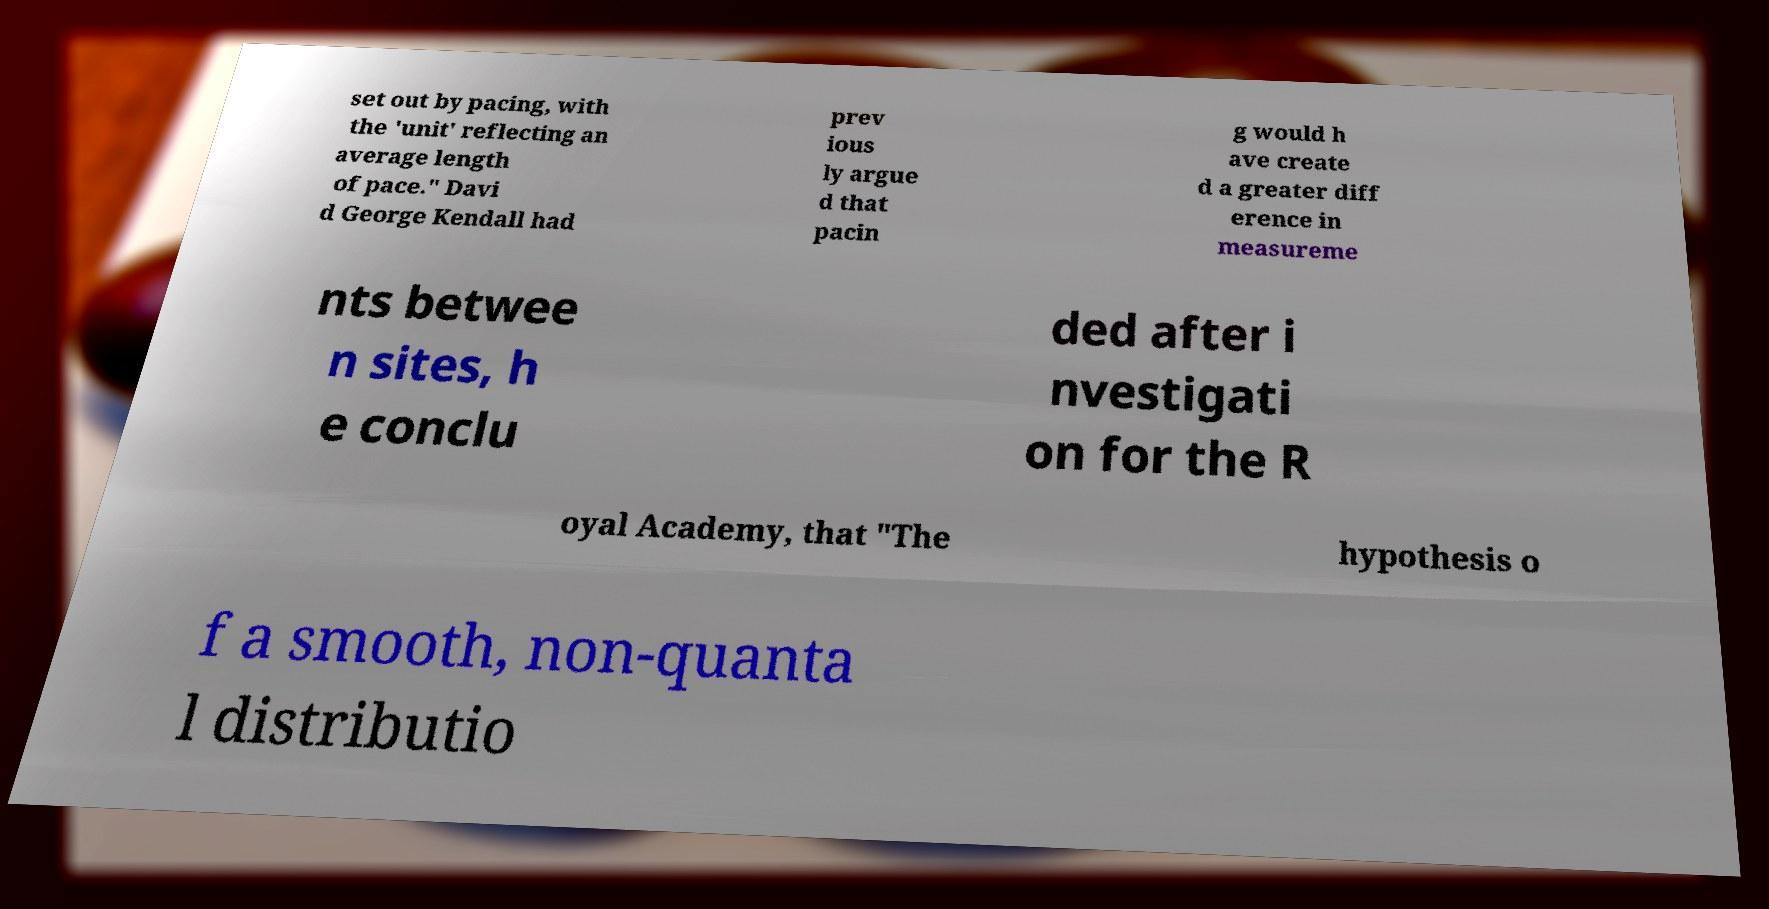Can you read and provide the text displayed in the image?This photo seems to have some interesting text. Can you extract and type it out for me? set out by pacing, with the 'unit' reflecting an average length of pace." Davi d George Kendall had prev ious ly argue d that pacin g would h ave create d a greater diff erence in measureme nts betwee n sites, h e conclu ded after i nvestigati on for the R oyal Academy, that "The hypothesis o f a smooth, non-quanta l distributio 